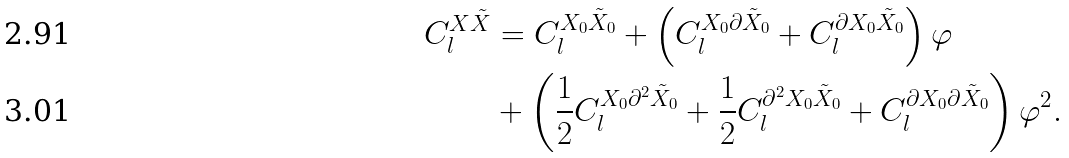Convert formula to latex. <formula><loc_0><loc_0><loc_500><loc_500>C _ { l } ^ { { X \tilde { X } } } & = C _ { l } ^ { { X _ { 0 } \tilde { X } _ { 0 } } } + \left ( C _ { l } ^ { { X _ { 0 } \partial \tilde { X } _ { 0 } } } + C _ { l } ^ { { \partial X _ { 0 } \tilde { X } _ { 0 } } } \right ) \varphi \\ & + \left ( \frac { 1 } { 2 } C _ { l } ^ { X _ { 0 } \partial ^ { 2 } \tilde { X } _ { 0 } } + \frac { 1 } { 2 } C _ { l } ^ { \partial ^ { 2 } X _ { 0 } \tilde { X } _ { 0 } } + C _ { l } ^ { \partial X _ { 0 } \partial \tilde { X } _ { 0 } } \right ) \varphi ^ { 2 } .</formula> 